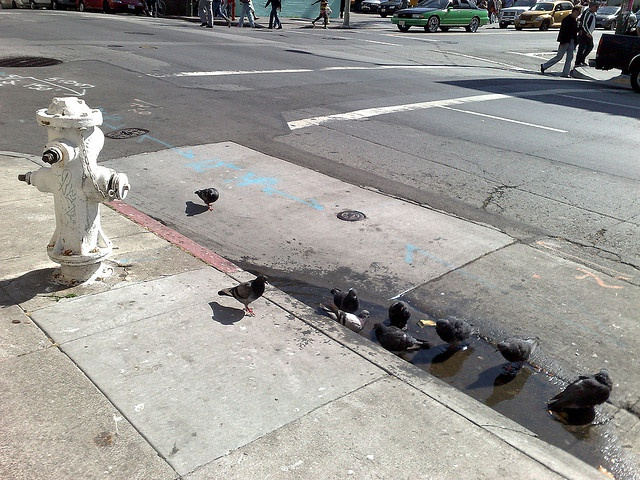Describe the objects in this image and their specific colors. I can see fire hydrant in gray, darkgray, and white tones, car in gray, black, darkgreen, and teal tones, car in gray, black, lightgray, and darkgray tones, bird in gray, black, and darkgray tones, and car in gray, black, and ivory tones in this image. 